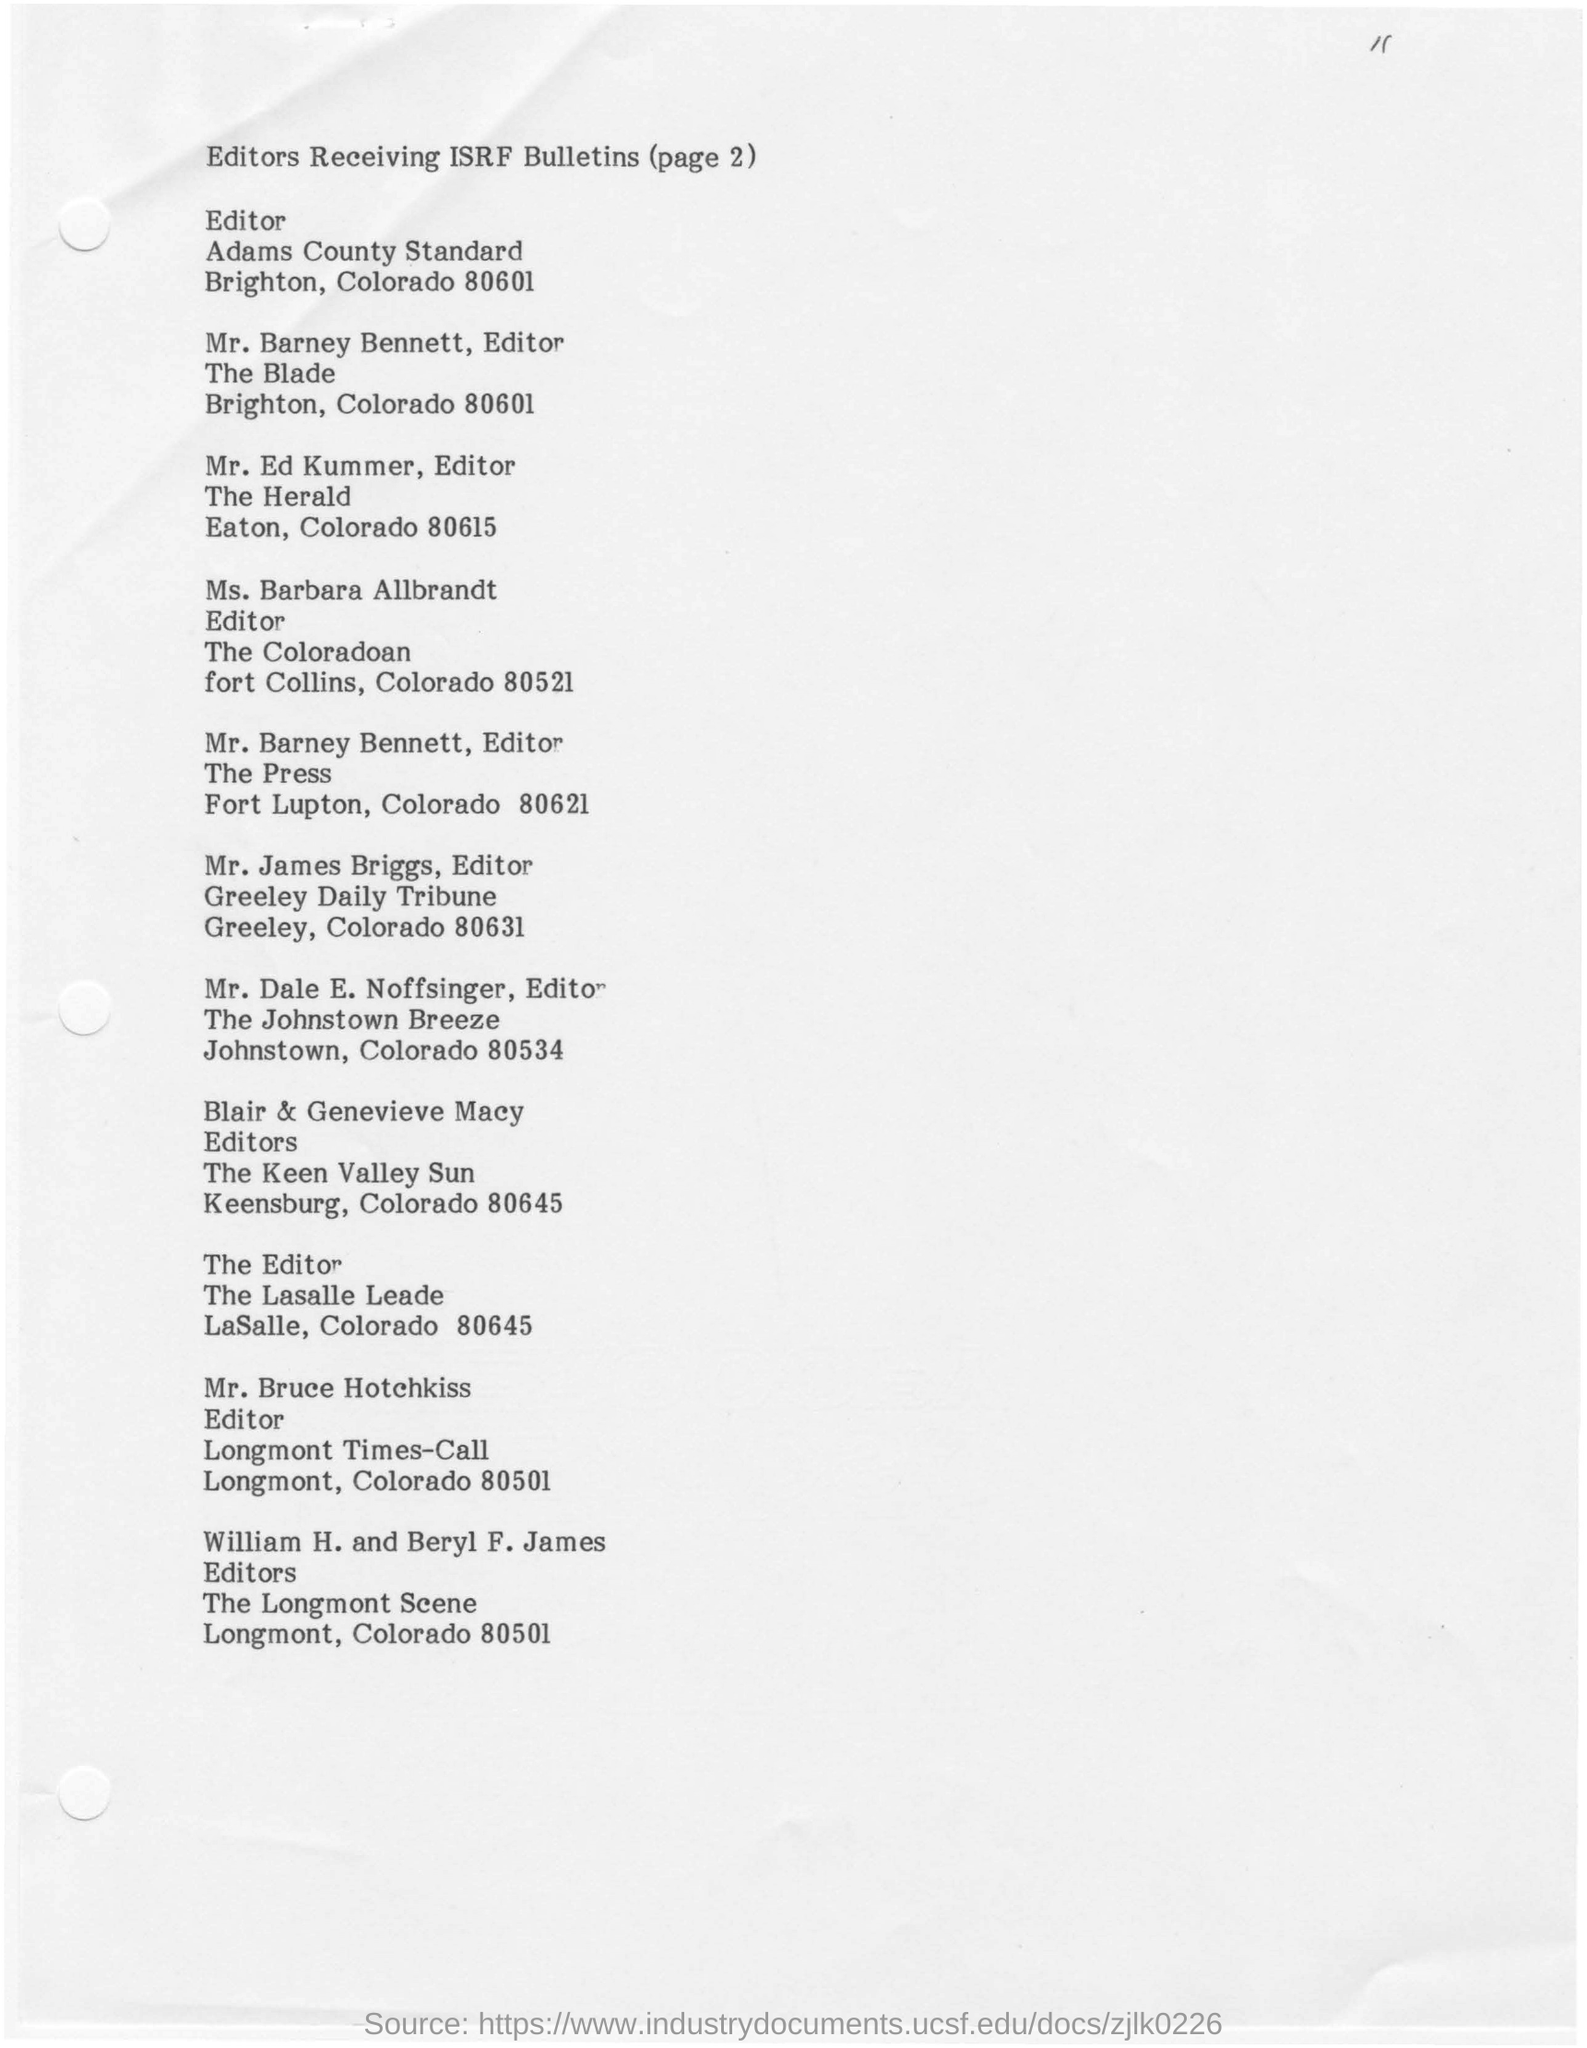List a handful of essential elements in this visual. The editor of The Colorado is Ms. Barbara Allbrandt. Mr. James Briggs is currently employed as an editor at the Greeley Daily Tribune. Blair and Genevieve Macy are the editors of... 